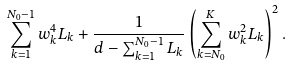Convert formula to latex. <formula><loc_0><loc_0><loc_500><loc_500>\sum _ { k = 1 } ^ { N _ { 0 } - 1 } w _ { k } ^ { 4 } L _ { k } + \frac { 1 } { d - \sum _ { k = 1 } ^ { N _ { 0 } - 1 } L _ { k } } \left ( \sum _ { k = N _ { 0 } } ^ { K } w _ { k } ^ { 2 } L _ { k } \right ) ^ { 2 } .</formula> 